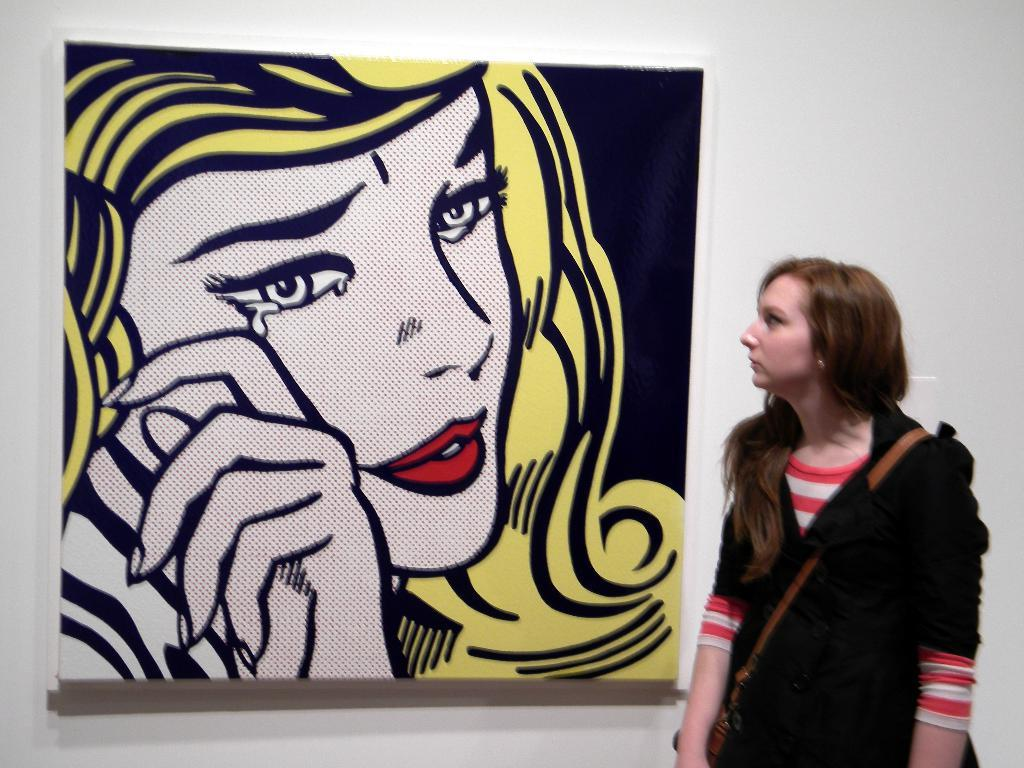Who is present in the image? There is a woman in the image. What is the woman wearing? The woman is wearing a bag. What can be seen in the background of the image? There is a wall in the background of the image. What is depicted on the wall? There is a painting of a lady on the wall. What is the woman using her tongue for in the image? There is no indication in the image that the woman is using her tongue for any purpose. 